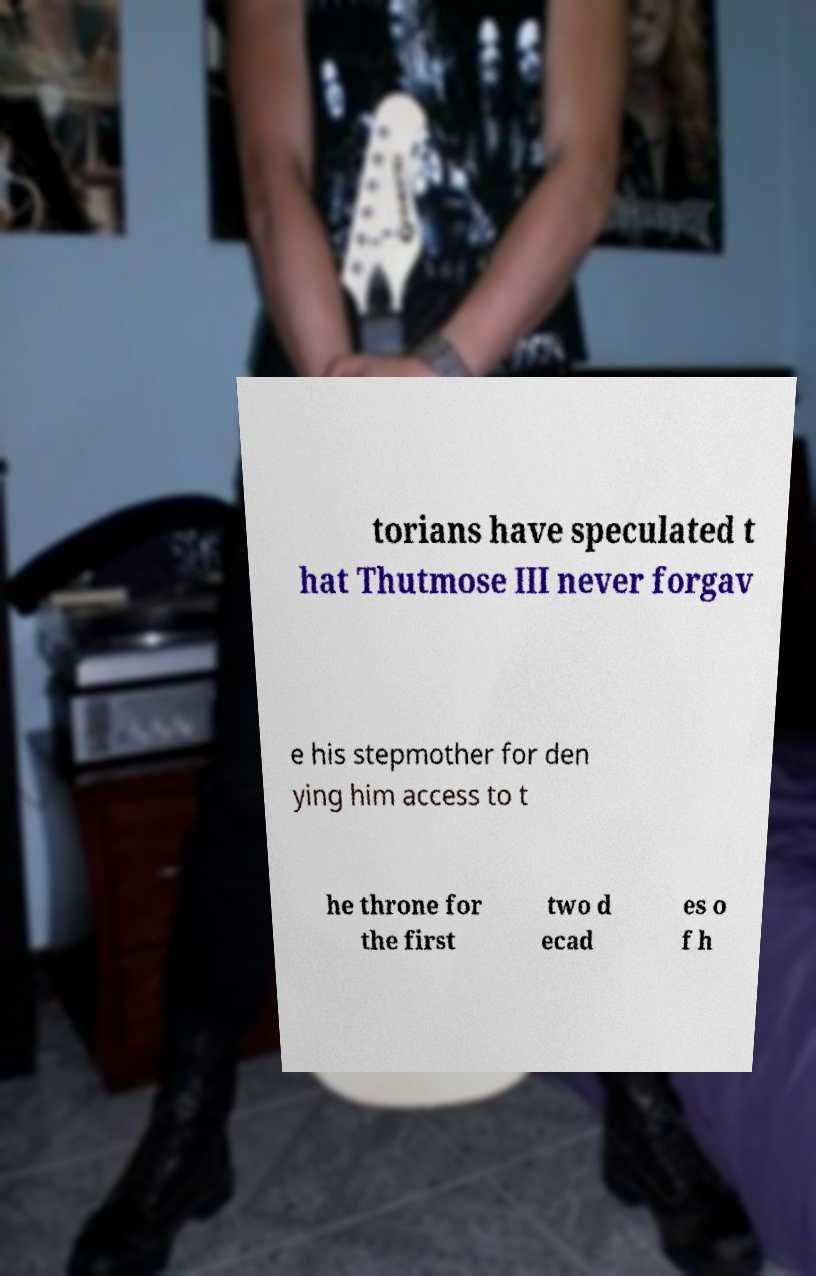Can you accurately transcribe the text from the provided image for me? torians have speculated t hat Thutmose III never forgav e his stepmother for den ying him access to t he throne for the first two d ecad es o f h 